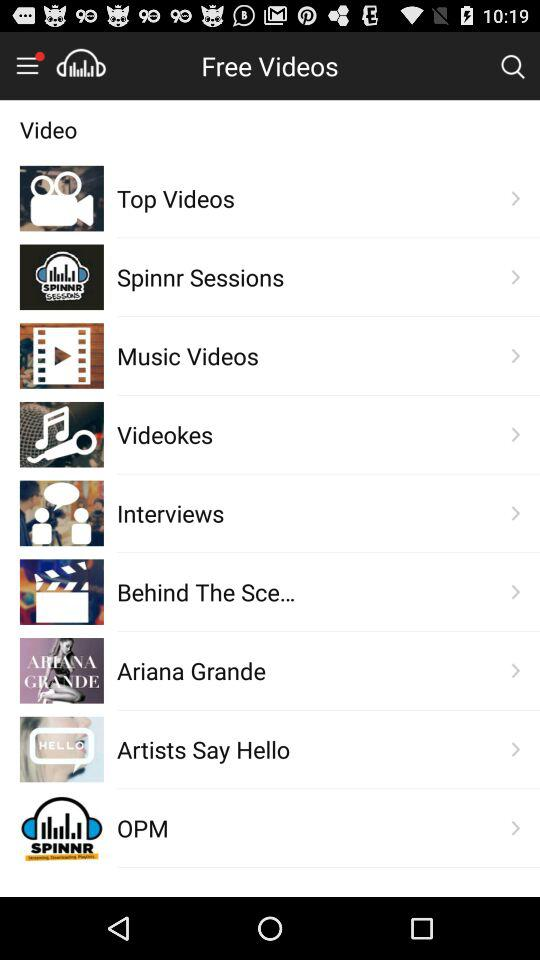What are the different available categories in "Free Videos"? The different available categories in "Free Videos" are "Top Videos", "Spinnr Sessions", "Music Videos", "Videokes", "Interviews", "Behind The Sce...", "Ariana Grande", "Artists Say Hello" and "OPM". 